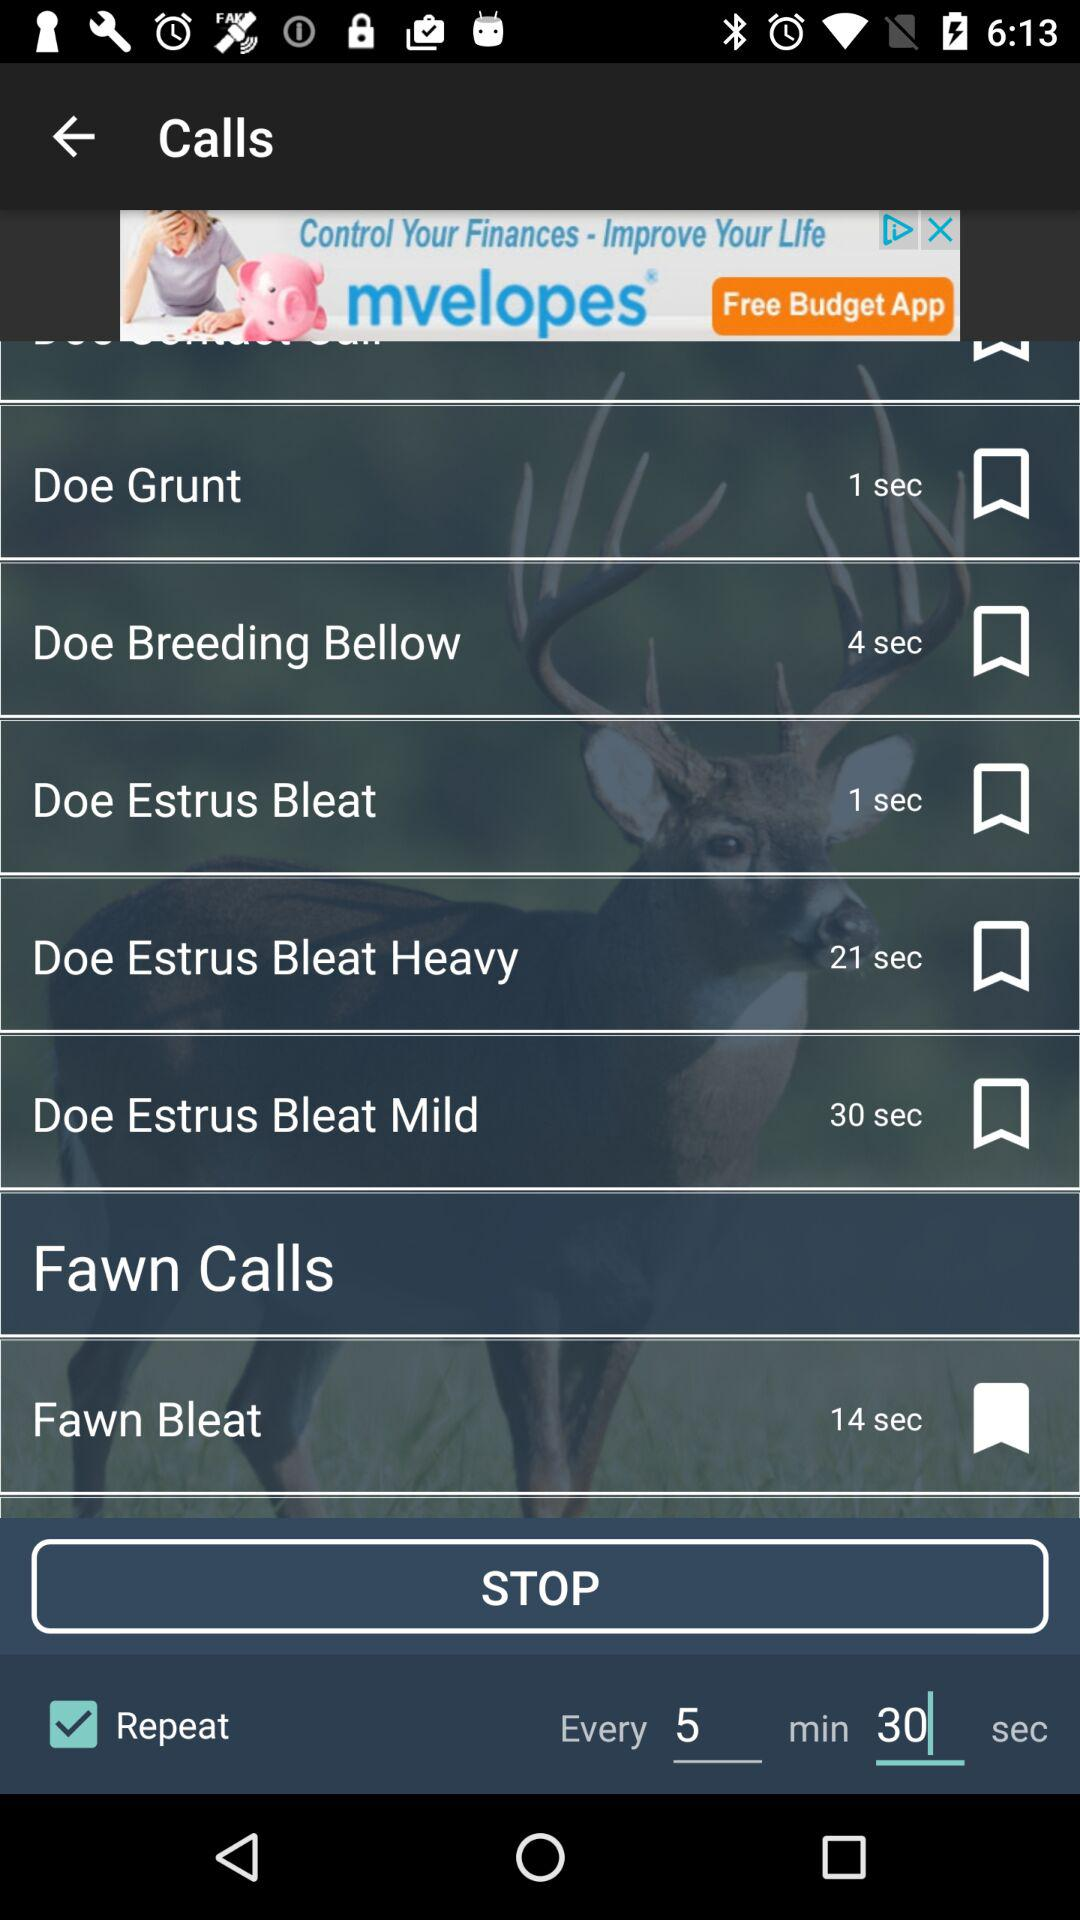How many more seconds is the Doe Estrus Bleat Heavy than the Doe Estrus Bleat Mild?
Answer the question using a single word or phrase. 9 